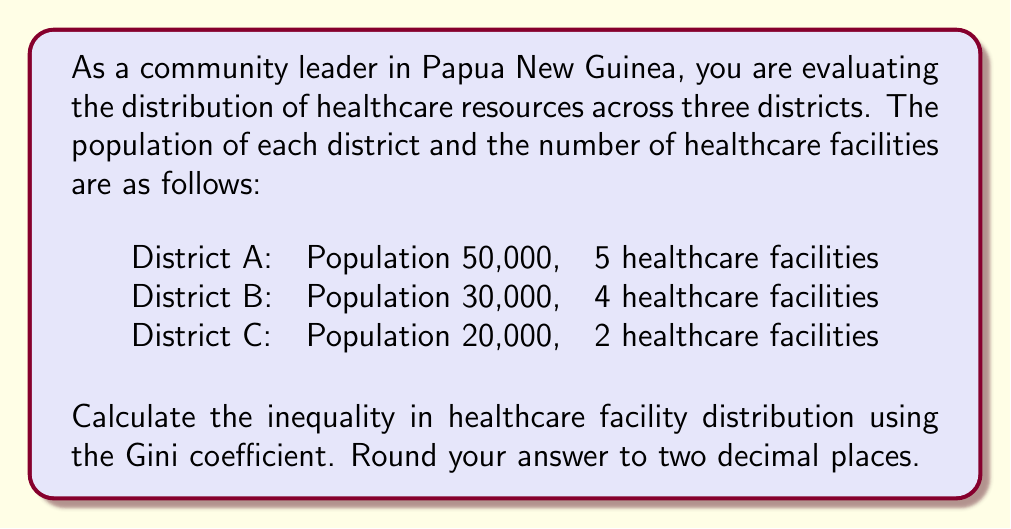Show me your answer to this math problem. To calculate the Gini coefficient for healthcare facility distribution, we'll follow these steps:

1. Calculate the proportion of population and healthcare facilities for each district:

   District A: 50% of population, 45.45% of facilities
   District B: 30% of population, 36.36% of facilities
   District C: 20% of population, 18.18% of facilities

2. Order the districts from lowest to highest facility proportion:

   C, A, B

3. Calculate cumulative proportions:

   Population: 20%, 70%, 100%
   Facilities: 18.18%, 63.63%, 100%

4. Calculate the area under the Lorenz curve:

   $$ A = 0.5 \times (0.2 \times 0.1818 + 0.7 \times 0.6363 + 1 \times 1) = 0.4818 $$

5. Calculate the area of perfect equality:

   $$ B = 0.5 $$

6. Calculate the Gini coefficient:

   $$ G = \frac{B - A}{B} = \frac{0.5 - 0.4818}{0.5} = 0.0364 $$

7. Round to two decimal places:

   $$ G \approx 0.04 $$
Answer: The Gini coefficient for healthcare facility distribution is approximately 0.04. 